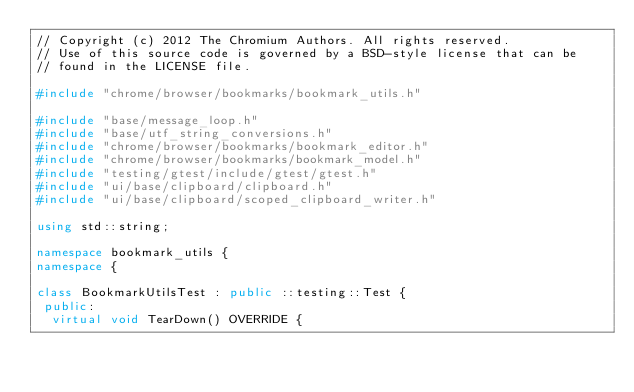<code> <loc_0><loc_0><loc_500><loc_500><_C++_>// Copyright (c) 2012 The Chromium Authors. All rights reserved.
// Use of this source code is governed by a BSD-style license that can be
// found in the LICENSE file.

#include "chrome/browser/bookmarks/bookmark_utils.h"

#include "base/message_loop.h"
#include "base/utf_string_conversions.h"
#include "chrome/browser/bookmarks/bookmark_editor.h"
#include "chrome/browser/bookmarks/bookmark_model.h"
#include "testing/gtest/include/gtest/gtest.h"
#include "ui/base/clipboard/clipboard.h"
#include "ui/base/clipboard/scoped_clipboard_writer.h"

using std::string;

namespace bookmark_utils {
namespace {

class BookmarkUtilsTest : public ::testing::Test {
 public:
  virtual void TearDown() OVERRIDE {</code> 